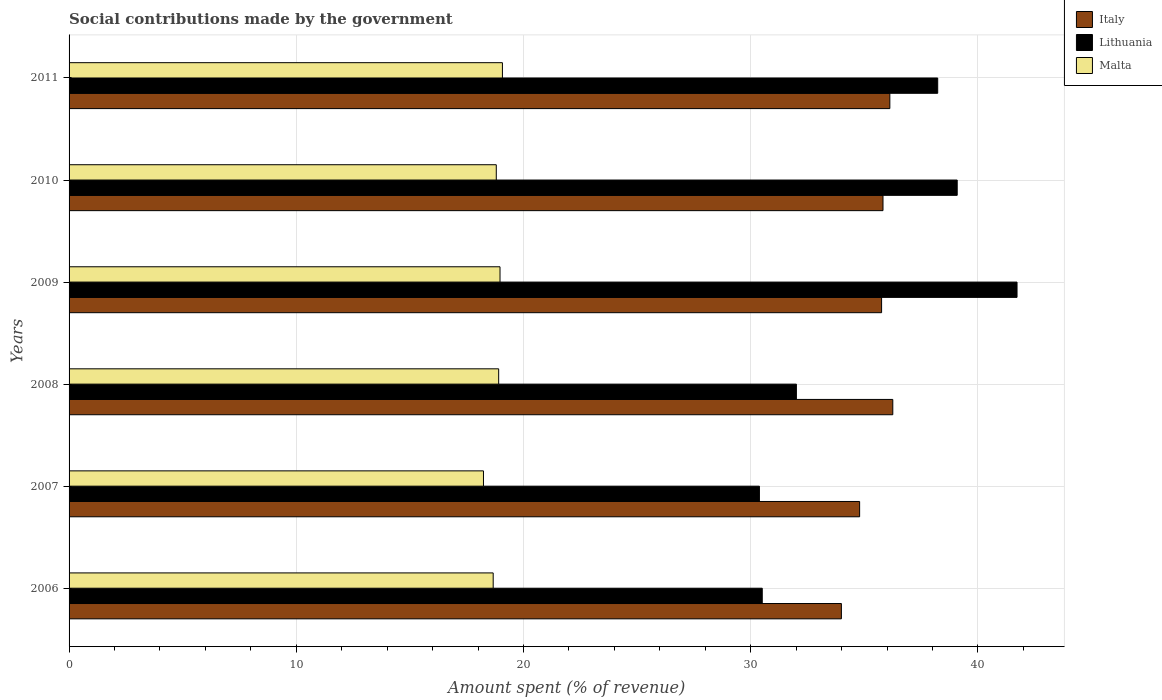How many different coloured bars are there?
Give a very brief answer. 3. How many groups of bars are there?
Provide a succinct answer. 6. Are the number of bars on each tick of the Y-axis equal?
Offer a terse response. Yes. How many bars are there on the 3rd tick from the bottom?
Your answer should be compact. 3. What is the amount spent (in %) on social contributions in Malta in 2011?
Give a very brief answer. 19.07. Across all years, what is the maximum amount spent (in %) on social contributions in Lithuania?
Give a very brief answer. 41.72. Across all years, what is the minimum amount spent (in %) on social contributions in Italy?
Your answer should be compact. 33.99. In which year was the amount spent (in %) on social contributions in Italy maximum?
Your response must be concise. 2008. What is the total amount spent (in %) on social contributions in Malta in the graph?
Offer a terse response. 112.65. What is the difference between the amount spent (in %) on social contributions in Italy in 2009 and that in 2010?
Your answer should be very brief. -0.06. What is the difference between the amount spent (in %) on social contributions in Malta in 2010 and the amount spent (in %) on social contributions in Italy in 2011?
Offer a very short reply. -17.32. What is the average amount spent (in %) on social contributions in Italy per year?
Your answer should be very brief. 35.46. In the year 2006, what is the difference between the amount spent (in %) on social contributions in Italy and amount spent (in %) on social contributions in Malta?
Your answer should be compact. 15.33. In how many years, is the amount spent (in %) on social contributions in Italy greater than 38 %?
Ensure brevity in your answer.  0. What is the ratio of the amount spent (in %) on social contributions in Lithuania in 2006 to that in 2009?
Offer a terse response. 0.73. Is the difference between the amount spent (in %) on social contributions in Italy in 2009 and 2010 greater than the difference between the amount spent (in %) on social contributions in Malta in 2009 and 2010?
Provide a succinct answer. No. What is the difference between the highest and the second highest amount spent (in %) on social contributions in Lithuania?
Your response must be concise. 2.63. What is the difference between the highest and the lowest amount spent (in %) on social contributions in Italy?
Your response must be concise. 2.26. In how many years, is the amount spent (in %) on social contributions in Malta greater than the average amount spent (in %) on social contributions in Malta taken over all years?
Your response must be concise. 4. What does the 2nd bar from the top in 2006 represents?
Give a very brief answer. Lithuania. What does the 2nd bar from the bottom in 2007 represents?
Provide a short and direct response. Lithuania. Are all the bars in the graph horizontal?
Offer a very short reply. Yes. Are the values on the major ticks of X-axis written in scientific E-notation?
Ensure brevity in your answer.  No. Does the graph contain any zero values?
Ensure brevity in your answer.  No. How are the legend labels stacked?
Make the answer very short. Vertical. What is the title of the graph?
Give a very brief answer. Social contributions made by the government. Does "Liberia" appear as one of the legend labels in the graph?
Provide a succinct answer. No. What is the label or title of the X-axis?
Make the answer very short. Amount spent (% of revenue). What is the Amount spent (% of revenue) in Italy in 2006?
Give a very brief answer. 33.99. What is the Amount spent (% of revenue) in Lithuania in 2006?
Keep it short and to the point. 30.51. What is the Amount spent (% of revenue) of Malta in 2006?
Offer a very short reply. 18.67. What is the Amount spent (% of revenue) of Italy in 2007?
Give a very brief answer. 34.79. What is the Amount spent (% of revenue) in Lithuania in 2007?
Provide a succinct answer. 30.38. What is the Amount spent (% of revenue) of Malta in 2007?
Offer a very short reply. 18.24. What is the Amount spent (% of revenue) in Italy in 2008?
Your answer should be very brief. 36.25. What is the Amount spent (% of revenue) in Lithuania in 2008?
Provide a succinct answer. 32.01. What is the Amount spent (% of revenue) of Malta in 2008?
Provide a short and direct response. 18.91. What is the Amount spent (% of revenue) of Italy in 2009?
Your response must be concise. 35.76. What is the Amount spent (% of revenue) in Lithuania in 2009?
Offer a terse response. 41.72. What is the Amount spent (% of revenue) in Malta in 2009?
Keep it short and to the point. 18.97. What is the Amount spent (% of revenue) of Italy in 2010?
Your response must be concise. 35.82. What is the Amount spent (% of revenue) in Lithuania in 2010?
Give a very brief answer. 39.09. What is the Amount spent (% of revenue) of Malta in 2010?
Provide a succinct answer. 18.8. What is the Amount spent (% of revenue) in Italy in 2011?
Your answer should be very brief. 36.12. What is the Amount spent (% of revenue) of Lithuania in 2011?
Your answer should be very brief. 38.23. What is the Amount spent (% of revenue) of Malta in 2011?
Keep it short and to the point. 19.07. Across all years, what is the maximum Amount spent (% of revenue) of Italy?
Provide a succinct answer. 36.25. Across all years, what is the maximum Amount spent (% of revenue) of Lithuania?
Give a very brief answer. 41.72. Across all years, what is the maximum Amount spent (% of revenue) of Malta?
Your answer should be very brief. 19.07. Across all years, what is the minimum Amount spent (% of revenue) in Italy?
Ensure brevity in your answer.  33.99. Across all years, what is the minimum Amount spent (% of revenue) in Lithuania?
Offer a terse response. 30.38. Across all years, what is the minimum Amount spent (% of revenue) in Malta?
Make the answer very short. 18.24. What is the total Amount spent (% of revenue) in Italy in the graph?
Make the answer very short. 212.75. What is the total Amount spent (% of revenue) in Lithuania in the graph?
Provide a short and direct response. 211.94. What is the total Amount spent (% of revenue) in Malta in the graph?
Ensure brevity in your answer.  112.65. What is the difference between the Amount spent (% of revenue) of Italy in 2006 and that in 2007?
Offer a very short reply. -0.8. What is the difference between the Amount spent (% of revenue) in Lithuania in 2006 and that in 2007?
Provide a short and direct response. 0.12. What is the difference between the Amount spent (% of revenue) in Malta in 2006 and that in 2007?
Provide a succinct answer. 0.43. What is the difference between the Amount spent (% of revenue) of Italy in 2006 and that in 2008?
Provide a succinct answer. -2.26. What is the difference between the Amount spent (% of revenue) in Lithuania in 2006 and that in 2008?
Provide a short and direct response. -1.5. What is the difference between the Amount spent (% of revenue) of Malta in 2006 and that in 2008?
Offer a very short reply. -0.24. What is the difference between the Amount spent (% of revenue) in Italy in 2006 and that in 2009?
Provide a short and direct response. -1.77. What is the difference between the Amount spent (% of revenue) of Lithuania in 2006 and that in 2009?
Offer a terse response. -11.21. What is the difference between the Amount spent (% of revenue) of Malta in 2006 and that in 2009?
Keep it short and to the point. -0.3. What is the difference between the Amount spent (% of revenue) of Italy in 2006 and that in 2010?
Provide a succinct answer. -1.83. What is the difference between the Amount spent (% of revenue) in Lithuania in 2006 and that in 2010?
Offer a very short reply. -8.58. What is the difference between the Amount spent (% of revenue) in Malta in 2006 and that in 2010?
Make the answer very short. -0.14. What is the difference between the Amount spent (% of revenue) in Italy in 2006 and that in 2011?
Provide a short and direct response. -2.13. What is the difference between the Amount spent (% of revenue) of Lithuania in 2006 and that in 2011?
Offer a terse response. -7.72. What is the difference between the Amount spent (% of revenue) in Malta in 2006 and that in 2011?
Your answer should be very brief. -0.41. What is the difference between the Amount spent (% of revenue) of Italy in 2007 and that in 2008?
Give a very brief answer. -1.46. What is the difference between the Amount spent (% of revenue) of Lithuania in 2007 and that in 2008?
Provide a short and direct response. -1.63. What is the difference between the Amount spent (% of revenue) of Malta in 2007 and that in 2008?
Ensure brevity in your answer.  -0.67. What is the difference between the Amount spent (% of revenue) of Italy in 2007 and that in 2009?
Offer a terse response. -0.97. What is the difference between the Amount spent (% of revenue) of Lithuania in 2007 and that in 2009?
Keep it short and to the point. -11.34. What is the difference between the Amount spent (% of revenue) in Malta in 2007 and that in 2009?
Provide a succinct answer. -0.73. What is the difference between the Amount spent (% of revenue) in Italy in 2007 and that in 2010?
Your response must be concise. -1.03. What is the difference between the Amount spent (% of revenue) in Lithuania in 2007 and that in 2010?
Offer a very short reply. -8.7. What is the difference between the Amount spent (% of revenue) in Malta in 2007 and that in 2010?
Keep it short and to the point. -0.56. What is the difference between the Amount spent (% of revenue) of Italy in 2007 and that in 2011?
Keep it short and to the point. -1.33. What is the difference between the Amount spent (% of revenue) of Lithuania in 2007 and that in 2011?
Offer a terse response. -7.85. What is the difference between the Amount spent (% of revenue) of Malta in 2007 and that in 2011?
Offer a terse response. -0.83. What is the difference between the Amount spent (% of revenue) of Italy in 2008 and that in 2009?
Ensure brevity in your answer.  0.49. What is the difference between the Amount spent (% of revenue) in Lithuania in 2008 and that in 2009?
Your response must be concise. -9.71. What is the difference between the Amount spent (% of revenue) of Malta in 2008 and that in 2009?
Provide a short and direct response. -0.06. What is the difference between the Amount spent (% of revenue) in Italy in 2008 and that in 2010?
Ensure brevity in your answer.  0.43. What is the difference between the Amount spent (% of revenue) in Lithuania in 2008 and that in 2010?
Make the answer very short. -7.08. What is the difference between the Amount spent (% of revenue) of Malta in 2008 and that in 2010?
Provide a succinct answer. 0.11. What is the difference between the Amount spent (% of revenue) of Italy in 2008 and that in 2011?
Your response must be concise. 0.13. What is the difference between the Amount spent (% of revenue) in Lithuania in 2008 and that in 2011?
Your answer should be very brief. -6.22. What is the difference between the Amount spent (% of revenue) of Malta in 2008 and that in 2011?
Keep it short and to the point. -0.17. What is the difference between the Amount spent (% of revenue) in Italy in 2009 and that in 2010?
Your answer should be compact. -0.06. What is the difference between the Amount spent (% of revenue) of Lithuania in 2009 and that in 2010?
Keep it short and to the point. 2.63. What is the difference between the Amount spent (% of revenue) of Malta in 2009 and that in 2010?
Your answer should be very brief. 0.16. What is the difference between the Amount spent (% of revenue) of Italy in 2009 and that in 2011?
Give a very brief answer. -0.36. What is the difference between the Amount spent (% of revenue) in Lithuania in 2009 and that in 2011?
Provide a succinct answer. 3.49. What is the difference between the Amount spent (% of revenue) in Malta in 2009 and that in 2011?
Keep it short and to the point. -0.11. What is the difference between the Amount spent (% of revenue) in Italy in 2010 and that in 2011?
Your answer should be compact. -0.3. What is the difference between the Amount spent (% of revenue) in Lithuania in 2010 and that in 2011?
Your answer should be very brief. 0.86. What is the difference between the Amount spent (% of revenue) of Malta in 2010 and that in 2011?
Offer a very short reply. -0.27. What is the difference between the Amount spent (% of revenue) of Italy in 2006 and the Amount spent (% of revenue) of Lithuania in 2007?
Your answer should be very brief. 3.61. What is the difference between the Amount spent (% of revenue) in Italy in 2006 and the Amount spent (% of revenue) in Malta in 2007?
Provide a succinct answer. 15.75. What is the difference between the Amount spent (% of revenue) in Lithuania in 2006 and the Amount spent (% of revenue) in Malta in 2007?
Your answer should be very brief. 12.27. What is the difference between the Amount spent (% of revenue) of Italy in 2006 and the Amount spent (% of revenue) of Lithuania in 2008?
Keep it short and to the point. 1.98. What is the difference between the Amount spent (% of revenue) of Italy in 2006 and the Amount spent (% of revenue) of Malta in 2008?
Keep it short and to the point. 15.08. What is the difference between the Amount spent (% of revenue) of Lithuania in 2006 and the Amount spent (% of revenue) of Malta in 2008?
Keep it short and to the point. 11.6. What is the difference between the Amount spent (% of revenue) in Italy in 2006 and the Amount spent (% of revenue) in Lithuania in 2009?
Provide a short and direct response. -7.73. What is the difference between the Amount spent (% of revenue) in Italy in 2006 and the Amount spent (% of revenue) in Malta in 2009?
Keep it short and to the point. 15.03. What is the difference between the Amount spent (% of revenue) in Lithuania in 2006 and the Amount spent (% of revenue) in Malta in 2009?
Provide a succinct answer. 11.54. What is the difference between the Amount spent (% of revenue) of Italy in 2006 and the Amount spent (% of revenue) of Lithuania in 2010?
Your answer should be very brief. -5.1. What is the difference between the Amount spent (% of revenue) of Italy in 2006 and the Amount spent (% of revenue) of Malta in 2010?
Offer a very short reply. 15.19. What is the difference between the Amount spent (% of revenue) of Lithuania in 2006 and the Amount spent (% of revenue) of Malta in 2010?
Provide a succinct answer. 11.71. What is the difference between the Amount spent (% of revenue) in Italy in 2006 and the Amount spent (% of revenue) in Lithuania in 2011?
Your answer should be very brief. -4.24. What is the difference between the Amount spent (% of revenue) of Italy in 2006 and the Amount spent (% of revenue) of Malta in 2011?
Your response must be concise. 14.92. What is the difference between the Amount spent (% of revenue) in Lithuania in 2006 and the Amount spent (% of revenue) in Malta in 2011?
Provide a succinct answer. 11.44. What is the difference between the Amount spent (% of revenue) of Italy in 2007 and the Amount spent (% of revenue) of Lithuania in 2008?
Your answer should be compact. 2.78. What is the difference between the Amount spent (% of revenue) in Italy in 2007 and the Amount spent (% of revenue) in Malta in 2008?
Offer a very short reply. 15.89. What is the difference between the Amount spent (% of revenue) of Lithuania in 2007 and the Amount spent (% of revenue) of Malta in 2008?
Ensure brevity in your answer.  11.48. What is the difference between the Amount spent (% of revenue) in Italy in 2007 and the Amount spent (% of revenue) in Lithuania in 2009?
Offer a very short reply. -6.93. What is the difference between the Amount spent (% of revenue) in Italy in 2007 and the Amount spent (% of revenue) in Malta in 2009?
Your response must be concise. 15.83. What is the difference between the Amount spent (% of revenue) in Lithuania in 2007 and the Amount spent (% of revenue) in Malta in 2009?
Offer a very short reply. 11.42. What is the difference between the Amount spent (% of revenue) of Italy in 2007 and the Amount spent (% of revenue) of Lithuania in 2010?
Your answer should be very brief. -4.29. What is the difference between the Amount spent (% of revenue) of Italy in 2007 and the Amount spent (% of revenue) of Malta in 2010?
Make the answer very short. 15.99. What is the difference between the Amount spent (% of revenue) of Lithuania in 2007 and the Amount spent (% of revenue) of Malta in 2010?
Provide a succinct answer. 11.58. What is the difference between the Amount spent (% of revenue) in Italy in 2007 and the Amount spent (% of revenue) in Lithuania in 2011?
Provide a succinct answer. -3.44. What is the difference between the Amount spent (% of revenue) of Italy in 2007 and the Amount spent (% of revenue) of Malta in 2011?
Keep it short and to the point. 15.72. What is the difference between the Amount spent (% of revenue) in Lithuania in 2007 and the Amount spent (% of revenue) in Malta in 2011?
Your response must be concise. 11.31. What is the difference between the Amount spent (% of revenue) in Italy in 2008 and the Amount spent (% of revenue) in Lithuania in 2009?
Provide a succinct answer. -5.47. What is the difference between the Amount spent (% of revenue) in Italy in 2008 and the Amount spent (% of revenue) in Malta in 2009?
Provide a succinct answer. 17.29. What is the difference between the Amount spent (% of revenue) in Lithuania in 2008 and the Amount spent (% of revenue) in Malta in 2009?
Give a very brief answer. 13.04. What is the difference between the Amount spent (% of revenue) in Italy in 2008 and the Amount spent (% of revenue) in Lithuania in 2010?
Provide a short and direct response. -2.83. What is the difference between the Amount spent (% of revenue) of Italy in 2008 and the Amount spent (% of revenue) of Malta in 2010?
Your answer should be very brief. 17.45. What is the difference between the Amount spent (% of revenue) of Lithuania in 2008 and the Amount spent (% of revenue) of Malta in 2010?
Your answer should be very brief. 13.21. What is the difference between the Amount spent (% of revenue) of Italy in 2008 and the Amount spent (% of revenue) of Lithuania in 2011?
Provide a succinct answer. -1.98. What is the difference between the Amount spent (% of revenue) of Italy in 2008 and the Amount spent (% of revenue) of Malta in 2011?
Give a very brief answer. 17.18. What is the difference between the Amount spent (% of revenue) of Lithuania in 2008 and the Amount spent (% of revenue) of Malta in 2011?
Your response must be concise. 12.94. What is the difference between the Amount spent (% of revenue) in Italy in 2009 and the Amount spent (% of revenue) in Lithuania in 2010?
Your answer should be compact. -3.33. What is the difference between the Amount spent (% of revenue) of Italy in 2009 and the Amount spent (% of revenue) of Malta in 2010?
Your answer should be very brief. 16.96. What is the difference between the Amount spent (% of revenue) of Lithuania in 2009 and the Amount spent (% of revenue) of Malta in 2010?
Offer a very short reply. 22.92. What is the difference between the Amount spent (% of revenue) in Italy in 2009 and the Amount spent (% of revenue) in Lithuania in 2011?
Your answer should be compact. -2.47. What is the difference between the Amount spent (% of revenue) of Italy in 2009 and the Amount spent (% of revenue) of Malta in 2011?
Make the answer very short. 16.69. What is the difference between the Amount spent (% of revenue) of Lithuania in 2009 and the Amount spent (% of revenue) of Malta in 2011?
Provide a succinct answer. 22.65. What is the difference between the Amount spent (% of revenue) of Italy in 2010 and the Amount spent (% of revenue) of Lithuania in 2011?
Offer a very short reply. -2.41. What is the difference between the Amount spent (% of revenue) in Italy in 2010 and the Amount spent (% of revenue) in Malta in 2011?
Offer a very short reply. 16.75. What is the difference between the Amount spent (% of revenue) in Lithuania in 2010 and the Amount spent (% of revenue) in Malta in 2011?
Provide a succinct answer. 20.02. What is the average Amount spent (% of revenue) of Italy per year?
Keep it short and to the point. 35.46. What is the average Amount spent (% of revenue) in Lithuania per year?
Make the answer very short. 35.32. What is the average Amount spent (% of revenue) of Malta per year?
Ensure brevity in your answer.  18.78. In the year 2006, what is the difference between the Amount spent (% of revenue) of Italy and Amount spent (% of revenue) of Lithuania?
Provide a short and direct response. 3.48. In the year 2006, what is the difference between the Amount spent (% of revenue) of Italy and Amount spent (% of revenue) of Malta?
Your answer should be compact. 15.33. In the year 2006, what is the difference between the Amount spent (% of revenue) in Lithuania and Amount spent (% of revenue) in Malta?
Ensure brevity in your answer.  11.84. In the year 2007, what is the difference between the Amount spent (% of revenue) in Italy and Amount spent (% of revenue) in Lithuania?
Provide a short and direct response. 4.41. In the year 2007, what is the difference between the Amount spent (% of revenue) in Italy and Amount spent (% of revenue) in Malta?
Keep it short and to the point. 16.56. In the year 2007, what is the difference between the Amount spent (% of revenue) of Lithuania and Amount spent (% of revenue) of Malta?
Ensure brevity in your answer.  12.15. In the year 2008, what is the difference between the Amount spent (% of revenue) in Italy and Amount spent (% of revenue) in Lithuania?
Provide a short and direct response. 4.24. In the year 2008, what is the difference between the Amount spent (% of revenue) in Italy and Amount spent (% of revenue) in Malta?
Offer a very short reply. 17.35. In the year 2008, what is the difference between the Amount spent (% of revenue) of Lithuania and Amount spent (% of revenue) of Malta?
Your response must be concise. 13.1. In the year 2009, what is the difference between the Amount spent (% of revenue) of Italy and Amount spent (% of revenue) of Lithuania?
Make the answer very short. -5.96. In the year 2009, what is the difference between the Amount spent (% of revenue) of Italy and Amount spent (% of revenue) of Malta?
Your answer should be very brief. 16.79. In the year 2009, what is the difference between the Amount spent (% of revenue) of Lithuania and Amount spent (% of revenue) of Malta?
Provide a short and direct response. 22.76. In the year 2010, what is the difference between the Amount spent (% of revenue) of Italy and Amount spent (% of revenue) of Lithuania?
Make the answer very short. -3.27. In the year 2010, what is the difference between the Amount spent (% of revenue) in Italy and Amount spent (% of revenue) in Malta?
Provide a short and direct response. 17.02. In the year 2010, what is the difference between the Amount spent (% of revenue) of Lithuania and Amount spent (% of revenue) of Malta?
Provide a succinct answer. 20.29. In the year 2011, what is the difference between the Amount spent (% of revenue) in Italy and Amount spent (% of revenue) in Lithuania?
Your answer should be very brief. -2.11. In the year 2011, what is the difference between the Amount spent (% of revenue) of Italy and Amount spent (% of revenue) of Malta?
Ensure brevity in your answer.  17.05. In the year 2011, what is the difference between the Amount spent (% of revenue) of Lithuania and Amount spent (% of revenue) of Malta?
Your response must be concise. 19.16. What is the ratio of the Amount spent (% of revenue) of Italy in 2006 to that in 2007?
Ensure brevity in your answer.  0.98. What is the ratio of the Amount spent (% of revenue) in Lithuania in 2006 to that in 2007?
Your response must be concise. 1. What is the ratio of the Amount spent (% of revenue) in Malta in 2006 to that in 2007?
Your answer should be very brief. 1.02. What is the ratio of the Amount spent (% of revenue) of Italy in 2006 to that in 2008?
Keep it short and to the point. 0.94. What is the ratio of the Amount spent (% of revenue) of Lithuania in 2006 to that in 2008?
Provide a succinct answer. 0.95. What is the ratio of the Amount spent (% of revenue) of Malta in 2006 to that in 2008?
Offer a terse response. 0.99. What is the ratio of the Amount spent (% of revenue) of Italy in 2006 to that in 2009?
Your answer should be compact. 0.95. What is the ratio of the Amount spent (% of revenue) of Lithuania in 2006 to that in 2009?
Offer a very short reply. 0.73. What is the ratio of the Amount spent (% of revenue) in Malta in 2006 to that in 2009?
Provide a short and direct response. 0.98. What is the ratio of the Amount spent (% of revenue) of Italy in 2006 to that in 2010?
Keep it short and to the point. 0.95. What is the ratio of the Amount spent (% of revenue) of Lithuania in 2006 to that in 2010?
Offer a very short reply. 0.78. What is the ratio of the Amount spent (% of revenue) in Italy in 2006 to that in 2011?
Offer a very short reply. 0.94. What is the ratio of the Amount spent (% of revenue) in Lithuania in 2006 to that in 2011?
Keep it short and to the point. 0.8. What is the ratio of the Amount spent (% of revenue) of Malta in 2006 to that in 2011?
Your response must be concise. 0.98. What is the ratio of the Amount spent (% of revenue) in Italy in 2007 to that in 2008?
Your response must be concise. 0.96. What is the ratio of the Amount spent (% of revenue) of Lithuania in 2007 to that in 2008?
Keep it short and to the point. 0.95. What is the ratio of the Amount spent (% of revenue) of Malta in 2007 to that in 2008?
Your answer should be compact. 0.96. What is the ratio of the Amount spent (% of revenue) of Lithuania in 2007 to that in 2009?
Make the answer very short. 0.73. What is the ratio of the Amount spent (% of revenue) of Malta in 2007 to that in 2009?
Keep it short and to the point. 0.96. What is the ratio of the Amount spent (% of revenue) of Italy in 2007 to that in 2010?
Provide a succinct answer. 0.97. What is the ratio of the Amount spent (% of revenue) of Lithuania in 2007 to that in 2010?
Your response must be concise. 0.78. What is the ratio of the Amount spent (% of revenue) in Italy in 2007 to that in 2011?
Make the answer very short. 0.96. What is the ratio of the Amount spent (% of revenue) in Lithuania in 2007 to that in 2011?
Your response must be concise. 0.79. What is the ratio of the Amount spent (% of revenue) of Malta in 2007 to that in 2011?
Your answer should be compact. 0.96. What is the ratio of the Amount spent (% of revenue) of Italy in 2008 to that in 2009?
Keep it short and to the point. 1.01. What is the ratio of the Amount spent (% of revenue) of Lithuania in 2008 to that in 2009?
Ensure brevity in your answer.  0.77. What is the ratio of the Amount spent (% of revenue) in Italy in 2008 to that in 2010?
Offer a terse response. 1.01. What is the ratio of the Amount spent (% of revenue) in Lithuania in 2008 to that in 2010?
Your answer should be very brief. 0.82. What is the ratio of the Amount spent (% of revenue) in Malta in 2008 to that in 2010?
Offer a terse response. 1.01. What is the ratio of the Amount spent (% of revenue) in Lithuania in 2008 to that in 2011?
Keep it short and to the point. 0.84. What is the ratio of the Amount spent (% of revenue) in Malta in 2008 to that in 2011?
Provide a short and direct response. 0.99. What is the ratio of the Amount spent (% of revenue) in Lithuania in 2009 to that in 2010?
Offer a terse response. 1.07. What is the ratio of the Amount spent (% of revenue) in Malta in 2009 to that in 2010?
Make the answer very short. 1.01. What is the ratio of the Amount spent (% of revenue) in Lithuania in 2009 to that in 2011?
Your answer should be very brief. 1.09. What is the ratio of the Amount spent (% of revenue) of Italy in 2010 to that in 2011?
Provide a succinct answer. 0.99. What is the ratio of the Amount spent (% of revenue) of Lithuania in 2010 to that in 2011?
Give a very brief answer. 1.02. What is the ratio of the Amount spent (% of revenue) of Malta in 2010 to that in 2011?
Your answer should be compact. 0.99. What is the difference between the highest and the second highest Amount spent (% of revenue) in Italy?
Give a very brief answer. 0.13. What is the difference between the highest and the second highest Amount spent (% of revenue) in Lithuania?
Give a very brief answer. 2.63. What is the difference between the highest and the second highest Amount spent (% of revenue) in Malta?
Keep it short and to the point. 0.11. What is the difference between the highest and the lowest Amount spent (% of revenue) in Italy?
Provide a succinct answer. 2.26. What is the difference between the highest and the lowest Amount spent (% of revenue) of Lithuania?
Give a very brief answer. 11.34. What is the difference between the highest and the lowest Amount spent (% of revenue) in Malta?
Give a very brief answer. 0.83. 